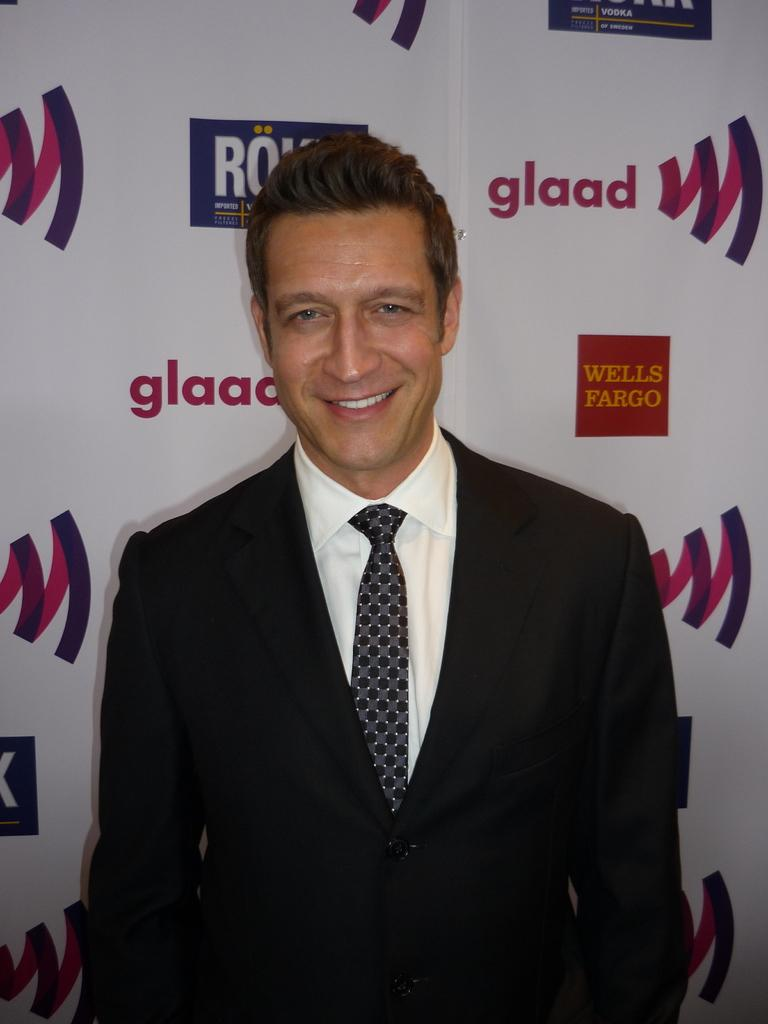Who is present in the image? There is a man in the image. What is the man doing in the image? The man is standing in the image. What expression does the man have on his face? The man is smiling in the image. What can be seen in the background of the image? There is a board visible in the background of the image. What type of wound can be seen on the man's arm in the image? There is no wound visible on the man's arm in the image. 